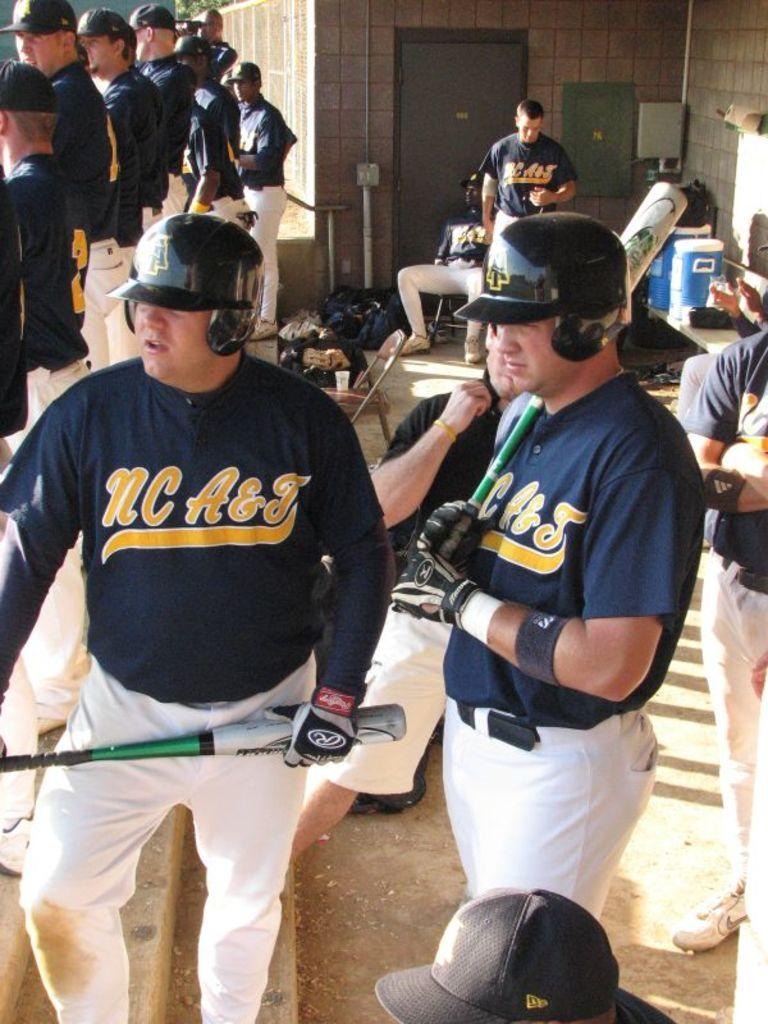Provide a one-sentence caption for the provided image. NC A & J baseball players holding bats. 